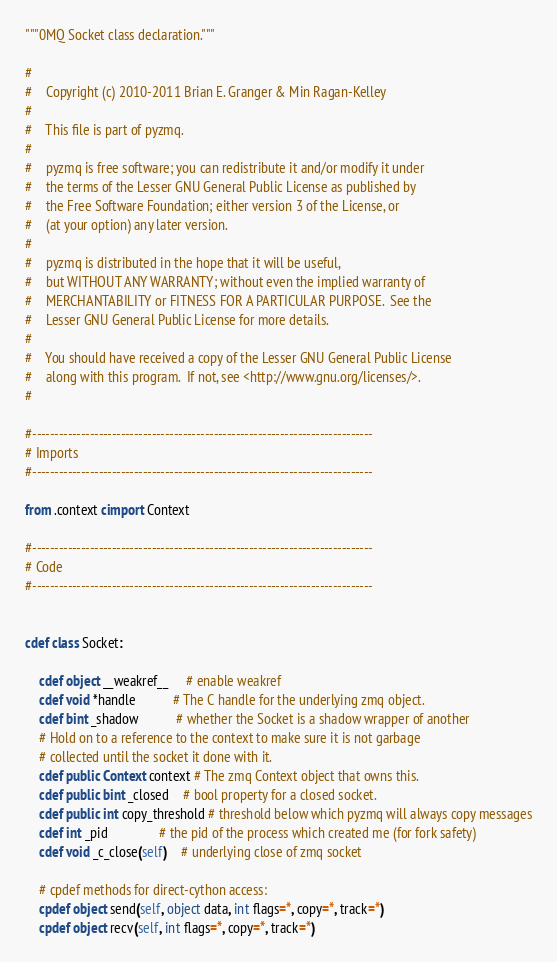<code> <loc_0><loc_0><loc_500><loc_500><_Cython_>"""0MQ Socket class declaration."""

#
#    Copyright (c) 2010-2011 Brian E. Granger & Min Ragan-Kelley
#
#    This file is part of pyzmq.
#
#    pyzmq is free software; you can redistribute it and/or modify it under
#    the terms of the Lesser GNU General Public License as published by
#    the Free Software Foundation; either version 3 of the License, or
#    (at your option) any later version.
#
#    pyzmq is distributed in the hope that it will be useful,
#    but WITHOUT ANY WARRANTY; without even the implied warranty of
#    MERCHANTABILITY or FITNESS FOR A PARTICULAR PURPOSE.  See the
#    Lesser GNU General Public License for more details.
#
#    You should have received a copy of the Lesser GNU General Public License
#    along with this program.  If not, see <http://www.gnu.org/licenses/>.
#

#-----------------------------------------------------------------------------
# Imports
#-----------------------------------------------------------------------------

from .context cimport Context

#-----------------------------------------------------------------------------
# Code
#-----------------------------------------------------------------------------


cdef class Socket:

    cdef object __weakref__     # enable weakref
    cdef void *handle           # The C handle for the underlying zmq object.
    cdef bint _shadow           # whether the Socket is a shadow wrapper of another
    # Hold on to a reference to the context to make sure it is not garbage
    # collected until the socket it done with it.
    cdef public Context context # The zmq Context object that owns this.
    cdef public bint _closed    # bool property for a closed socket.
    cdef public int copy_threshold # threshold below which pyzmq will always copy messages
    cdef int _pid               # the pid of the process which created me (for fork safety)
    cdef void _c_close(self)    # underlying close of zmq socket

    # cpdef methods for direct-cython access:
    cpdef object send(self, object data, int flags=*, copy=*, track=*)
    cpdef object recv(self, int flags=*, copy=*, track=*)

</code> 